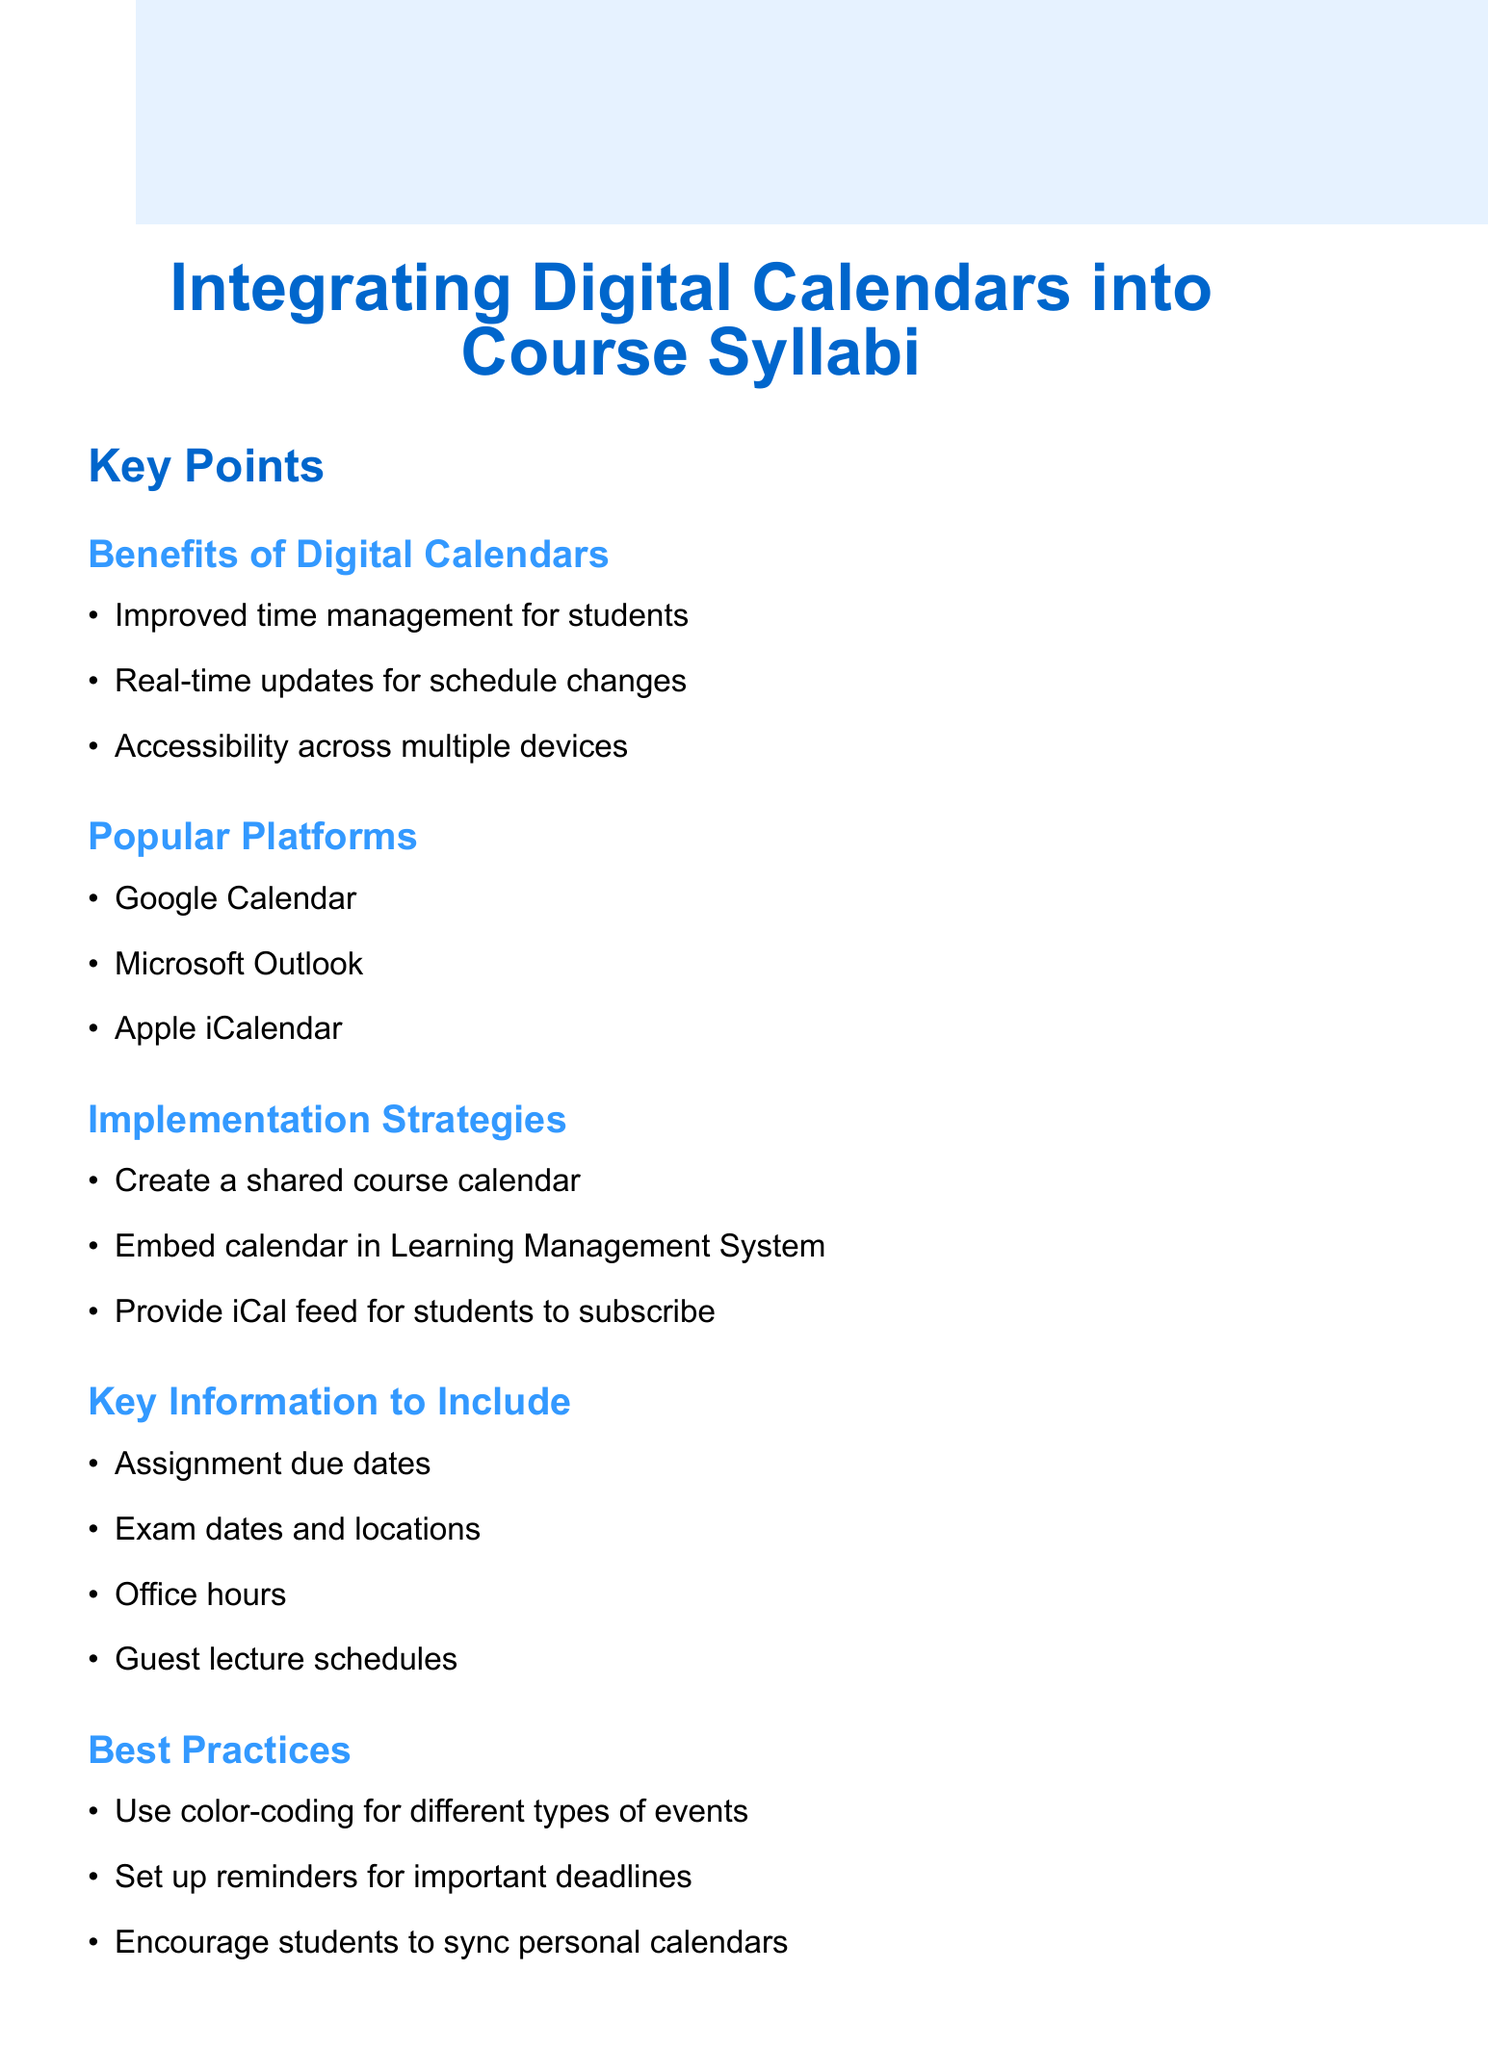What are the benefits of digital calendars? The document lists specific benefits in a bullet format under the section "Benefits of Digital Calendars," highlighting time management, real-time updates, and accessibility.
Answer: Improved time management for students, Real-time updates for schedule changes, Accessibility across multiple devices What are three popular digital calendar platforms mentioned? The document outlines popular digital calendar platforms in the "Popular digital calendar platforms" section, providing examples in a list format.
Answer: Google Calendar, Microsoft Outlook, Apple iCalendar What key information should be included in the calendar? The document specifies key items to be included in the calendar under the section "Key Information to Include," formatted as a bulleted list.
Answer: Assignment due dates, Exam dates and locations, Office hours, Guest lecture schedules What is one best practice suggested for using digital calendars? The document mentions best practices related to digital calendar usage in the section "Best Practices," providing tips in a bullet point format.
Answer: Use color-coding for different types of events What are two potential challenges of integrating digital calendars? The document addresses potential challenges in the section "Addressing Potential Challenges," outlining various issues in list form.
Answer: Ensuring all students have access, Maintaining consistency across platforms 